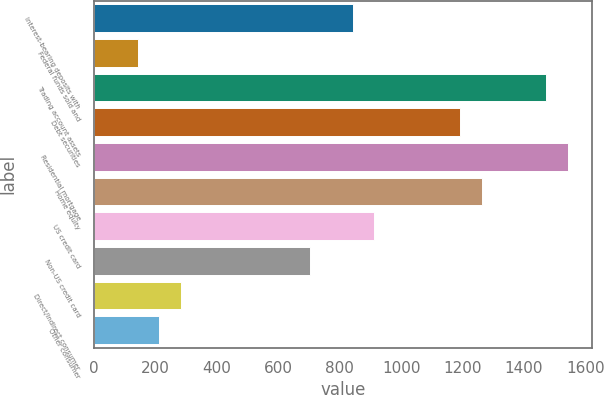Convert chart to OTSL. <chart><loc_0><loc_0><loc_500><loc_500><bar_chart><fcel>Interest-bearing deposits with<fcel>Federal funds sold and<fcel>Trading account assets<fcel>Debt securities<fcel>Residential mortgage<fcel>Home equity<fcel>US credit card<fcel>Non-US credit card<fcel>Direct/Indirect consumer<fcel>Other consumer<nl><fcel>842.2<fcel>141.2<fcel>1473.1<fcel>1192.7<fcel>1543.2<fcel>1262.8<fcel>912.3<fcel>702<fcel>281.4<fcel>211.3<nl></chart> 